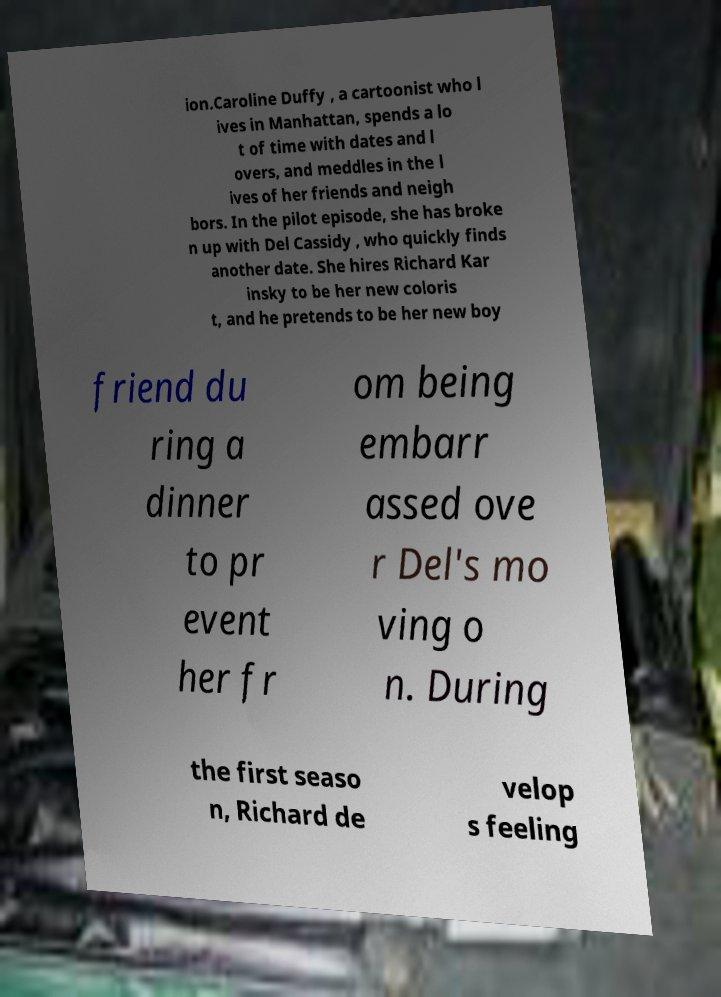There's text embedded in this image that I need extracted. Can you transcribe it verbatim? ion.Caroline Duffy , a cartoonist who l ives in Manhattan, spends a lo t of time with dates and l overs, and meddles in the l ives of her friends and neigh bors. In the pilot episode, she has broke n up with Del Cassidy , who quickly finds another date. She hires Richard Kar insky to be her new coloris t, and he pretends to be her new boy friend du ring a dinner to pr event her fr om being embarr assed ove r Del's mo ving o n. During the first seaso n, Richard de velop s feeling 